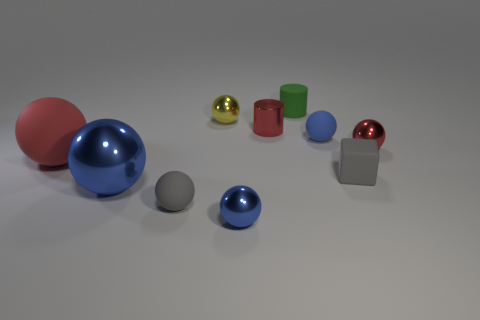How many blue spheres must be subtracted to get 1 blue spheres? 2 Subtract all matte balls. How many balls are left? 4 Subtract all yellow balls. How many balls are left? 6 Subtract all balls. How many objects are left? 3 Subtract 1 cylinders. How many cylinders are left? 1 Subtract all green spheres. Subtract all green blocks. How many spheres are left? 7 Subtract all gray cubes. How many red cylinders are left? 1 Subtract all small blocks. Subtract all tiny gray rubber things. How many objects are left? 7 Add 3 tiny metal objects. How many tiny metal objects are left? 7 Add 5 small matte cylinders. How many small matte cylinders exist? 6 